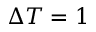Convert formula to latex. <formula><loc_0><loc_0><loc_500><loc_500>\Delta T = 1</formula> 